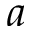Convert formula to latex. <formula><loc_0><loc_0><loc_500><loc_500>a</formula> 